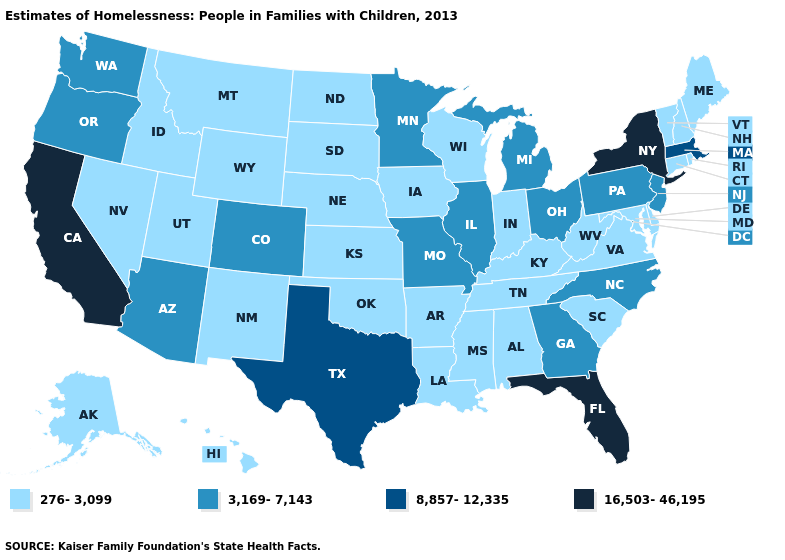What is the value of Washington?
Short answer required. 3,169-7,143. What is the value of South Dakota?
Quick response, please. 276-3,099. What is the lowest value in the USA?
Be succinct. 276-3,099. What is the value of New Jersey?
Short answer required. 3,169-7,143. Is the legend a continuous bar?
Short answer required. No. Name the states that have a value in the range 276-3,099?
Answer briefly. Alabama, Alaska, Arkansas, Connecticut, Delaware, Hawaii, Idaho, Indiana, Iowa, Kansas, Kentucky, Louisiana, Maine, Maryland, Mississippi, Montana, Nebraska, Nevada, New Hampshire, New Mexico, North Dakota, Oklahoma, Rhode Island, South Carolina, South Dakota, Tennessee, Utah, Vermont, Virginia, West Virginia, Wisconsin, Wyoming. What is the highest value in states that border South Carolina?
Answer briefly. 3,169-7,143. Which states hav the highest value in the Northeast?
Be succinct. New York. Name the states that have a value in the range 16,503-46,195?
Quick response, please. California, Florida, New York. Among the states that border Nevada , which have the highest value?
Write a very short answer. California. Does Washington have a higher value than Illinois?
Quick response, please. No. Which states have the lowest value in the USA?
Keep it brief. Alabama, Alaska, Arkansas, Connecticut, Delaware, Hawaii, Idaho, Indiana, Iowa, Kansas, Kentucky, Louisiana, Maine, Maryland, Mississippi, Montana, Nebraska, Nevada, New Hampshire, New Mexico, North Dakota, Oklahoma, Rhode Island, South Carolina, South Dakota, Tennessee, Utah, Vermont, Virginia, West Virginia, Wisconsin, Wyoming. Name the states that have a value in the range 3,169-7,143?
Write a very short answer. Arizona, Colorado, Georgia, Illinois, Michigan, Minnesota, Missouri, New Jersey, North Carolina, Ohio, Oregon, Pennsylvania, Washington. What is the highest value in the South ?
Write a very short answer. 16,503-46,195. Does Montana have the lowest value in the USA?
Short answer required. Yes. 